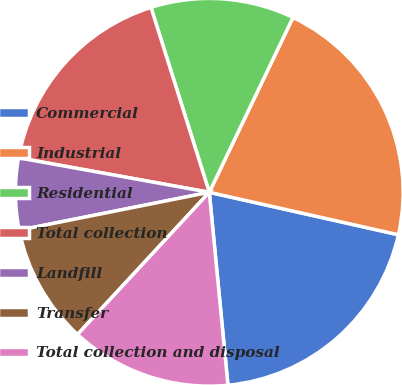<chart> <loc_0><loc_0><loc_500><loc_500><pie_chart><fcel>Commercial<fcel>Industrial<fcel>Residential<fcel>Total collection<fcel>Landfill<fcel>Transfer<fcel>Total collection and disposal<nl><fcel>19.95%<fcel>21.41%<fcel>11.97%<fcel>17.29%<fcel>5.98%<fcel>9.97%<fcel>13.43%<nl></chart> 